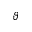Convert formula to latex. <formula><loc_0><loc_0><loc_500><loc_500>\vartheta</formula> 